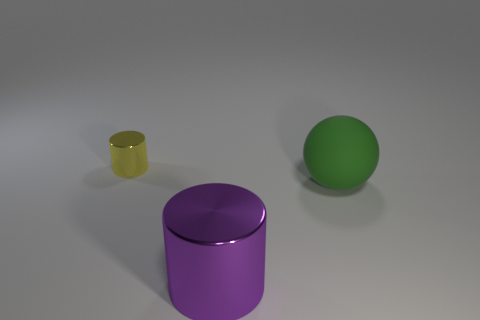What color is the object that is the same size as the ball?
Provide a succinct answer. Purple. Is there any other thing that is the same color as the big shiny object?
Offer a very short reply. No. How big is the metallic object left of the shiny thing that is in front of the small yellow object that is to the left of the big green ball?
Provide a short and direct response. Small. There is a object that is both in front of the yellow metallic thing and left of the big green thing; what is its color?
Ensure brevity in your answer.  Purple. There is a sphere that is in front of the yellow cylinder; what size is it?
Provide a succinct answer. Large. What number of yellow spheres are made of the same material as the tiny yellow cylinder?
Ensure brevity in your answer.  0. There is a large object in front of the big green thing; is its shape the same as the yellow metallic thing?
Offer a very short reply. Yes. What is the color of the large thing that is made of the same material as the yellow cylinder?
Your answer should be compact. Purple. Is there a purple metal object that is in front of the metal cylinder that is on the right side of the cylinder behind the large green object?
Offer a very short reply. No. The large purple metallic object has what shape?
Provide a short and direct response. Cylinder. 